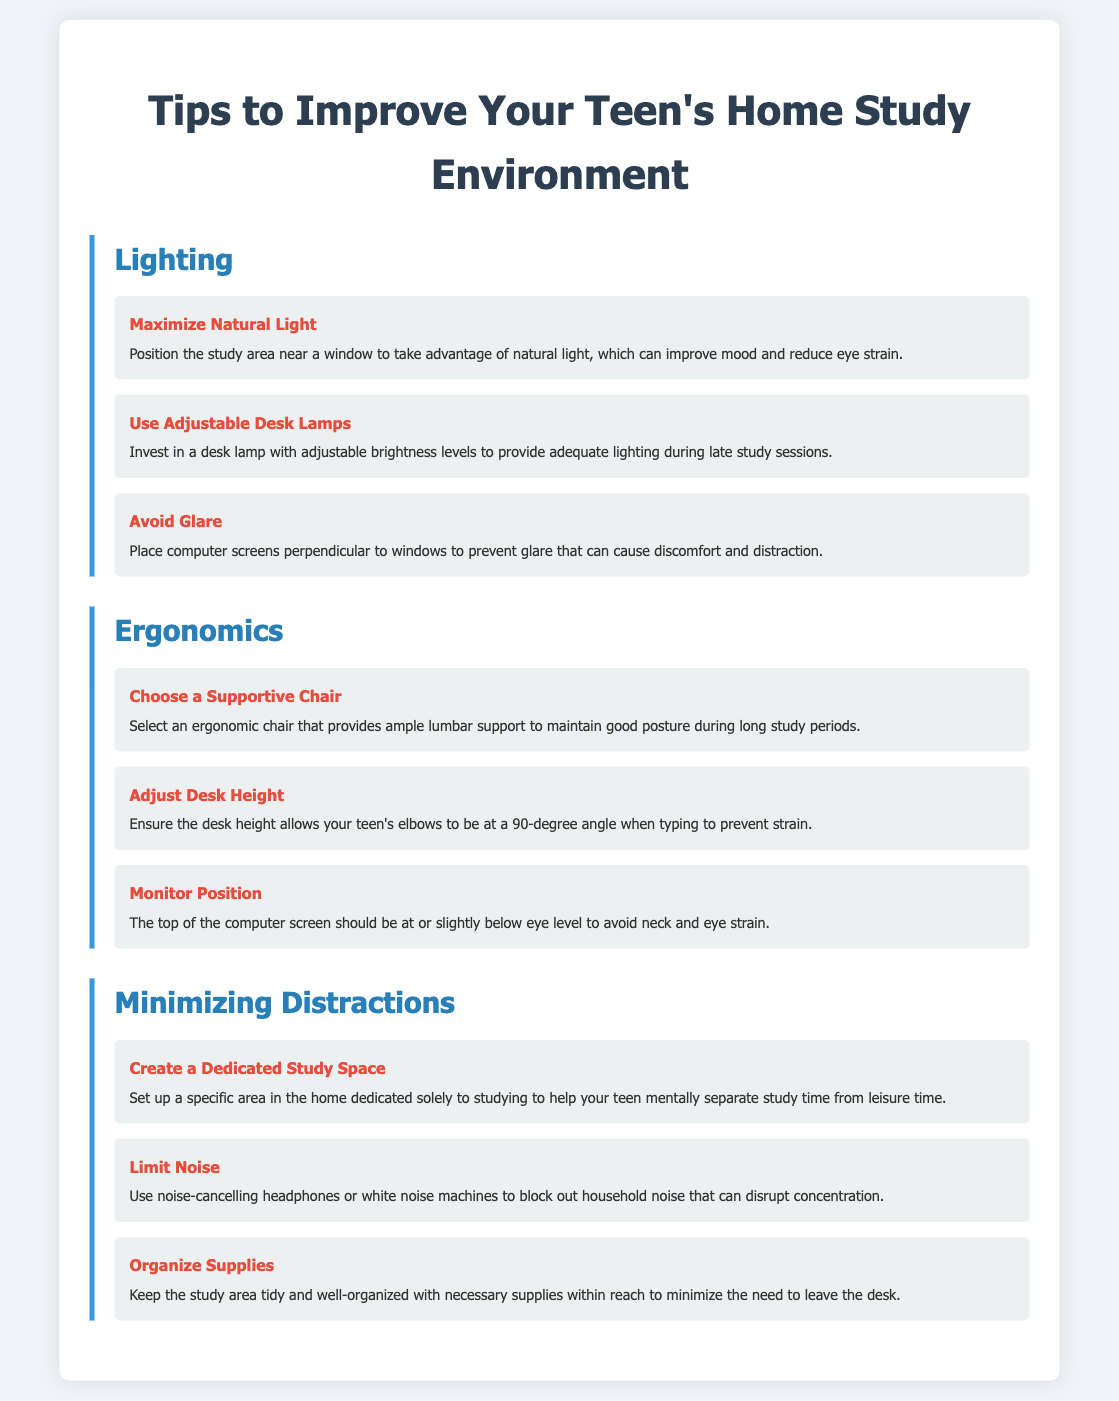What is the main title of the document? The main title appears at the top of the infographic, summarizing its focus on improving home study environments for teens.
Answer: Tips to Improve Your Teen's Home Study Environment How many sections are there in the infographic? The infographic is divided into three main sections: Lighting, Ergonomics, and Minimizing Distractions.
Answer: 3 What is one tip for maximizing natural light? The specific recommendation for maximizing natural light is to position the study area near a window.
Answer: Position the study area near a window What should the desk height allow for when typing? The document specifies that desk height should allow elbows to be at a 90-degree angle while typing to prevent strain.
Answer: 90-degree angle What is a method suggested for limiting noise? The infographic recommends using noise-cancelling headphones or white noise machines as a method to limit noise.
Answer: Noise-cancelling headphones or white noise machines Which tip addresses the organization of study supplies? The tip titled "Organize Supplies" focuses on keeping the study area tidy and well-organized, enabling easy access to necessary supplies.
Answer: Organize Supplies What is the recommended position for the top of the computer screen? The document states that the top of the computer screen should be at or slightly below eye level to avoid neck and eye strain.
Answer: At or slightly below eye level How does the infographic suggest to avoid glare? The recommended method to avoid glare includes placing computer screens perpendicular to windows.
Answer: Place computer screens perpendicular to windows 